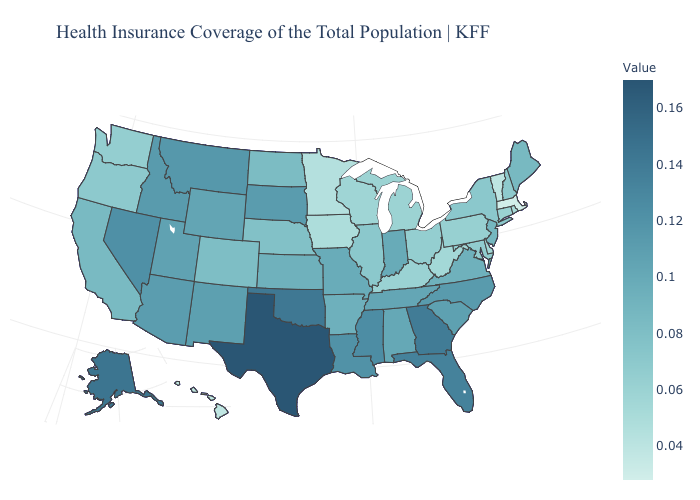Does Texas have the highest value in the USA?
Answer briefly. Yes. Among the states that border Wisconsin , does Michigan have the lowest value?
Answer briefly. No. Among the states that border Nebraska , does Iowa have the lowest value?
Write a very short answer. Yes. Does the map have missing data?
Give a very brief answer. No. Which states have the lowest value in the USA?
Answer briefly. Massachusetts. 